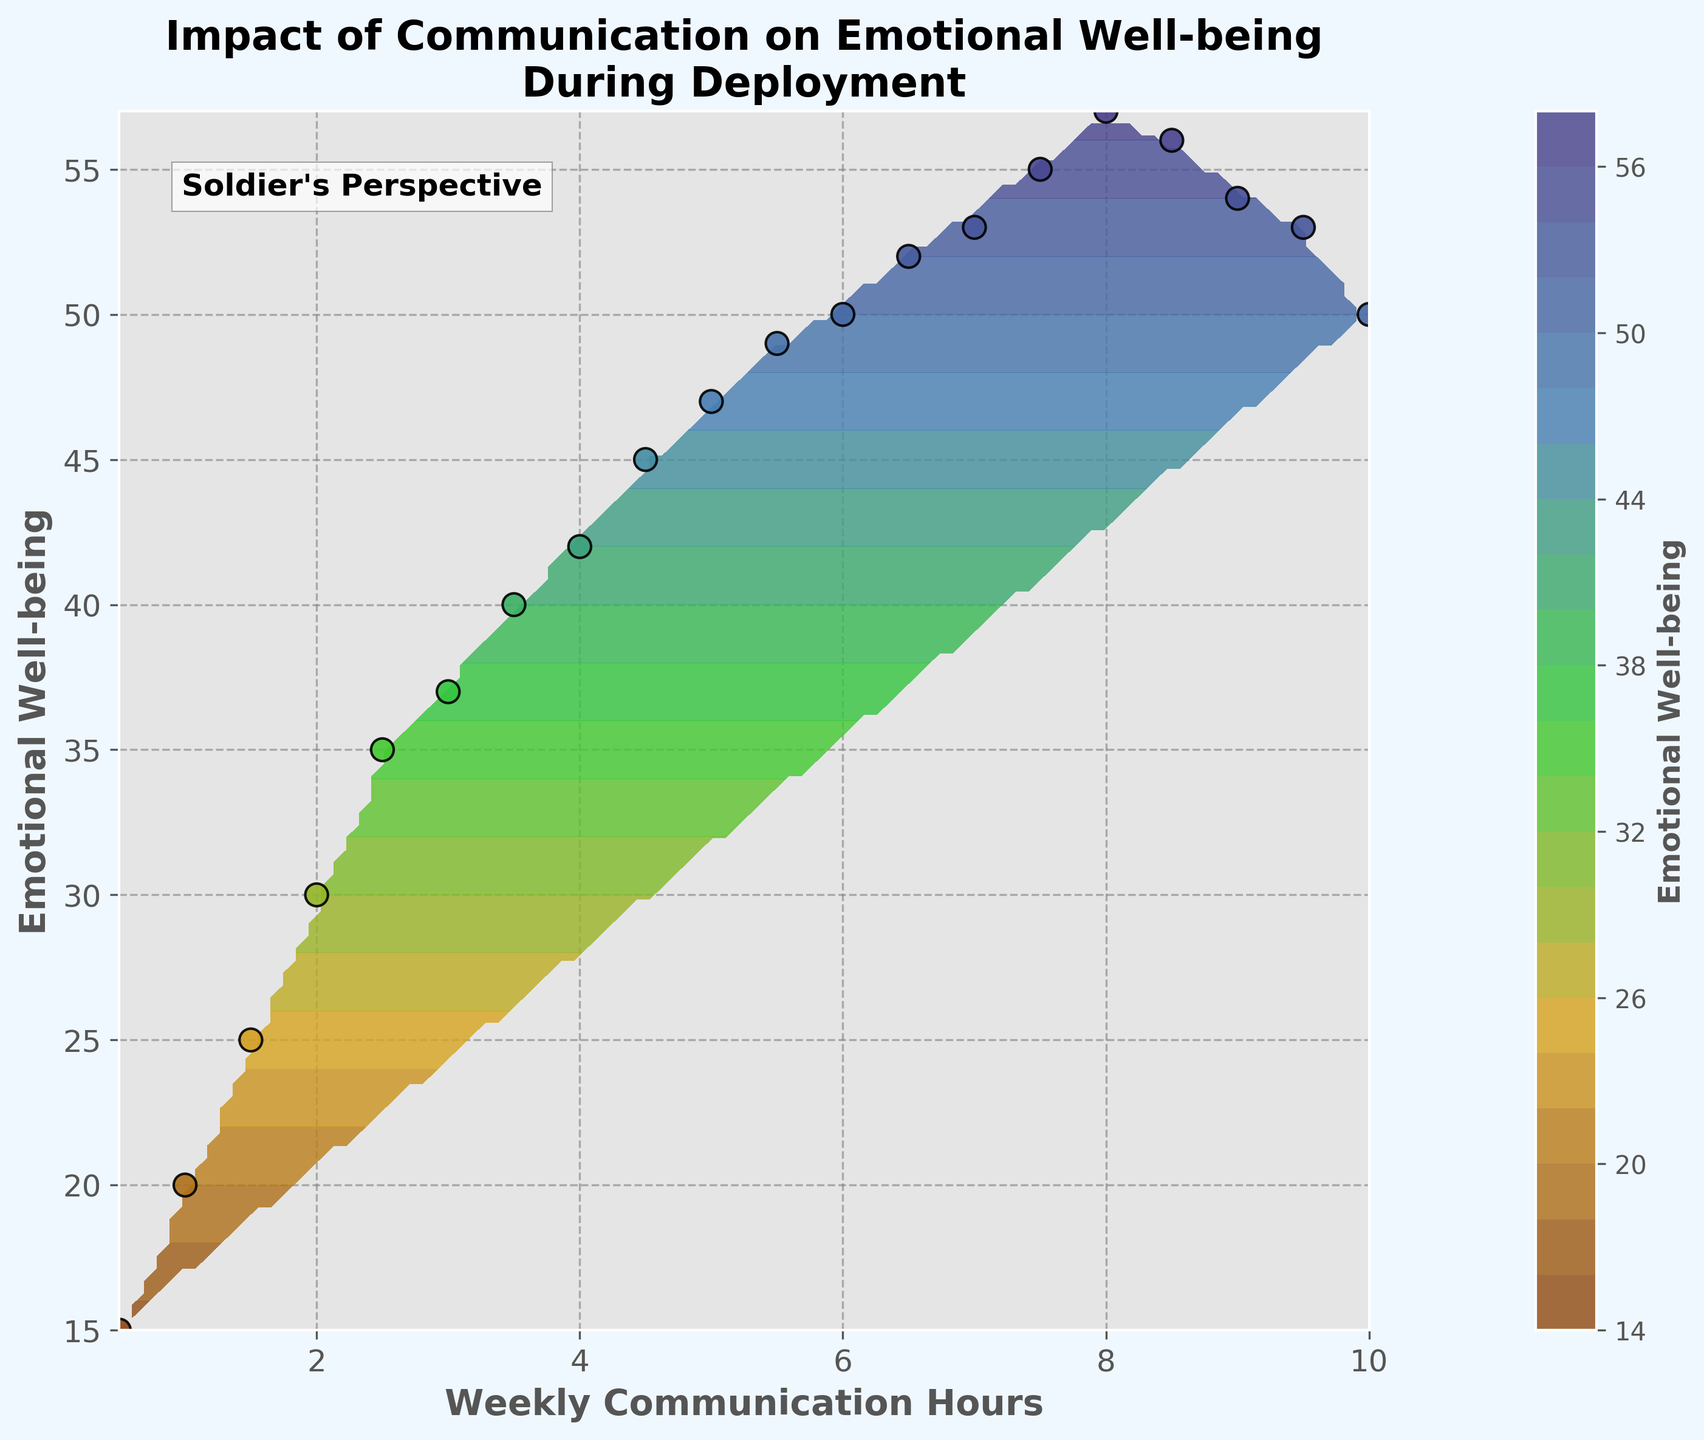What is the title of the plot? The title is usually positioned at the top of the figure and provides a concise description of what the plot represents. Observing the title can help understand the figure's main focus quickly.
Answer: Impact of Communication on Emotional Well-being During Deployment What are the labels of the X and Y axes? The X-axis and Y-axis labels are typically placed adjacent to their respective axes. They help in understanding what quantities are being plotted. The X-axis label is on the bottom, and the Y-axis label is on the left side of the figure.
Answer: Weekly Communication Hours (X), Emotional Well-being (Y) How many data points are shown in the scatter plot? Each data point on the scatter plot is represented by a marker (circle) with an edge color. Counting these markers gives the number of data points.
Answer: 20 What is the range of weekly communication hours shown in the figure? The range of the X-axis shows the minimum and maximum values of weekly communication hours. Observing the X-axis ticks can help determine this range.
Answer: 0.5 to 10 hours How does the emotional well-being change as weekly communication hours increase from 0.5 to around 6 hours? Observing the general trend in the scatter plot and contour lines between these points will show whether emotional well-being increases, decreases, or stays constant. From 0.5 to 6 hours, there is a noticeable upward trend in emotional well-being.
Answer: It increases What is the emotional well-being value at the lowest communication hour? Locate the data point with the lowest X-axis value, which is 0.5 hours, and read the corresponding Y-axis value for emotional well-being.
Answer: 15 At which communication hour does emotional well-being peak? Identify the highest point (Y-axis value) in the scatter plot and note down the corresponding X-axis value for weekly communication hours.
Answer: 8 hours Compare the emotional well-being for 3 hours vs. 9 hours of weekly communication. Which is higher? Locate the points at 3 and 9 hours on the X-axis and observe their corresponding Y-values. Comparing the two values determines which is higher. Emotional well-being at 3 hours is 37, while at 9 hours, it is 54.
Answer: 9 hours What trend can be observed in emotional well-being for communication hours from 8.5 to 10? Examine the scatter plot and contour lines between 8.5 and 10 hours of communication. Noticing whether the points go up, down, or stay constant reveals the trend. Emotional well-being peaks around 8 hours and then slightly decreases towards 10 hours.
Answer: It decreases slightly Which region on the contour plot shows the highest concentration of high emotional well-being values? The contour plot uses colors to represent different levels of emotional well-being. Identify the region with the darkest or most intense color corresponding to high values. The region from 6 to 8.5 weekly hours generally shows the highest emotional well-being.
Answer: 6 to 8.5 weekly hours 